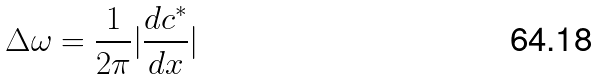Convert formula to latex. <formula><loc_0><loc_0><loc_500><loc_500>\Delta \omega = \frac { 1 } { 2 \pi } | \frac { d c ^ { \ast } } { d x } |</formula> 